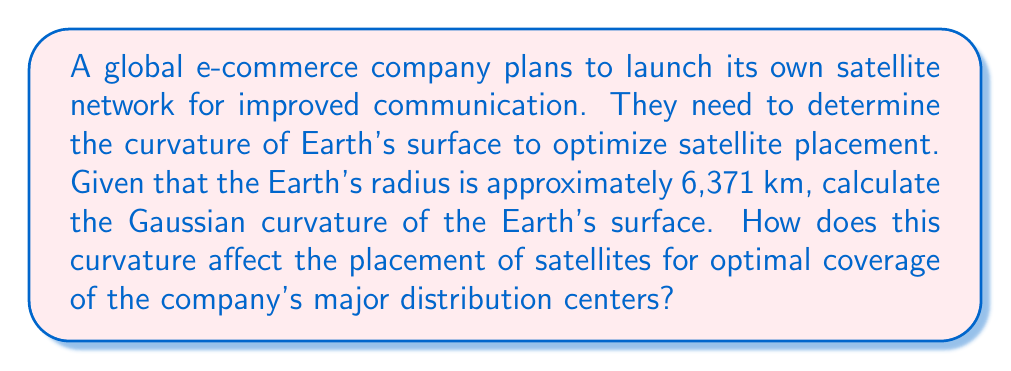Provide a solution to this math problem. To solve this problem, we'll follow these steps:

1. Recall the formula for Gaussian curvature of a sphere:
   The Gaussian curvature $K$ of a sphere with radius $R$ is given by:
   
   $$K = \frac{1}{R^2}$$

2. Calculate the Gaussian curvature of the Earth:
   Given: Earth's radius $R = 6,371$ km
   
   $$K = \frac{1}{(6,371 \text{ km})^2} = 2.46 \times 10^{-14} \text{ km}^{-2}$$

3. Interpret the result:
   The positive curvature indicates that the Earth's surface is convex. This means that satellite signals will have to be directed at an angle to reach the surface effectively.

4. Consider the impact on satellite placement:
   - The curvature affects the optimal height for satellites to achieve the best coverage.
   - Geostationary satellites are typically placed at an altitude of about 35,786 km above the Earth's surface.
   - The company needs to consider the curvature when calculating the footprint (area of coverage) for each satellite.

5. Optimize coverage for distribution centers:
   - The company should place satellites to maximize coverage over their major distribution centers.
   - The curvature affects the angle at which signals must be sent and received, impacting the number of satellites needed for global coverage.
   - For areas near the equator, fewer satellites are needed due to the Earth's rotation.
   - For polar regions, more satellites or different orbits may be required due to the Earth's curvature.

6. Consider the impact on network latency:
   - The curvature affects the distance signals must travel, impacting network latency.
   - The company may need to use a combination of geostationary and low Earth orbit satellites to balance coverage and latency for their e-commerce operations.
Answer: $2.46 \times 10^{-14} \text{ km}^{-2}$; affects satellite height, coverage area, and signal angles. 